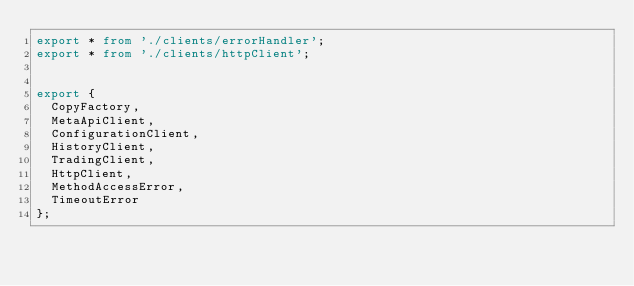<code> <loc_0><loc_0><loc_500><loc_500><_TypeScript_>export * from './clients/errorHandler';
export * from './clients/httpClient';


export {
  CopyFactory, 
  MetaApiClient, 
  ConfigurationClient, 
  HistoryClient,
  TradingClient,
  HttpClient,
  MethodAccessError, 
  TimeoutError
};
</code> 